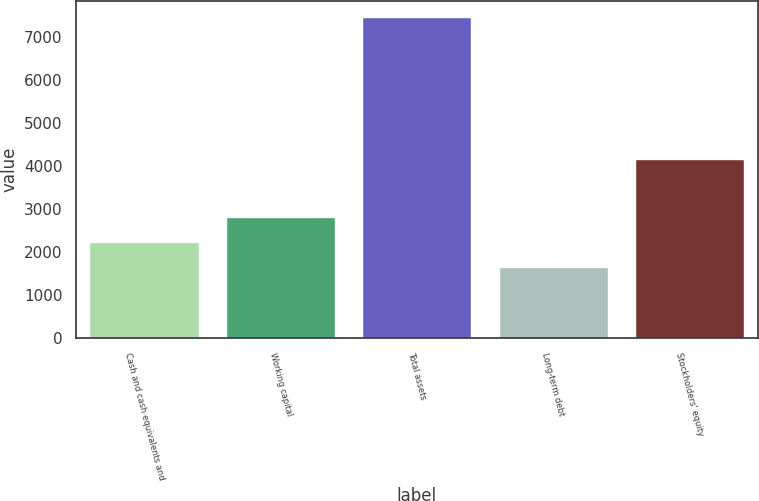Convert chart. <chart><loc_0><loc_0><loc_500><loc_500><bar_chart><fcel>Cash and cash equivalents and<fcel>Working capital<fcel>Total assets<fcel>Long-term debt<fcel>Stockholders' equity<nl><fcel>2237.4<fcel>2819.8<fcel>7479<fcel>1655<fcel>4167<nl></chart> 